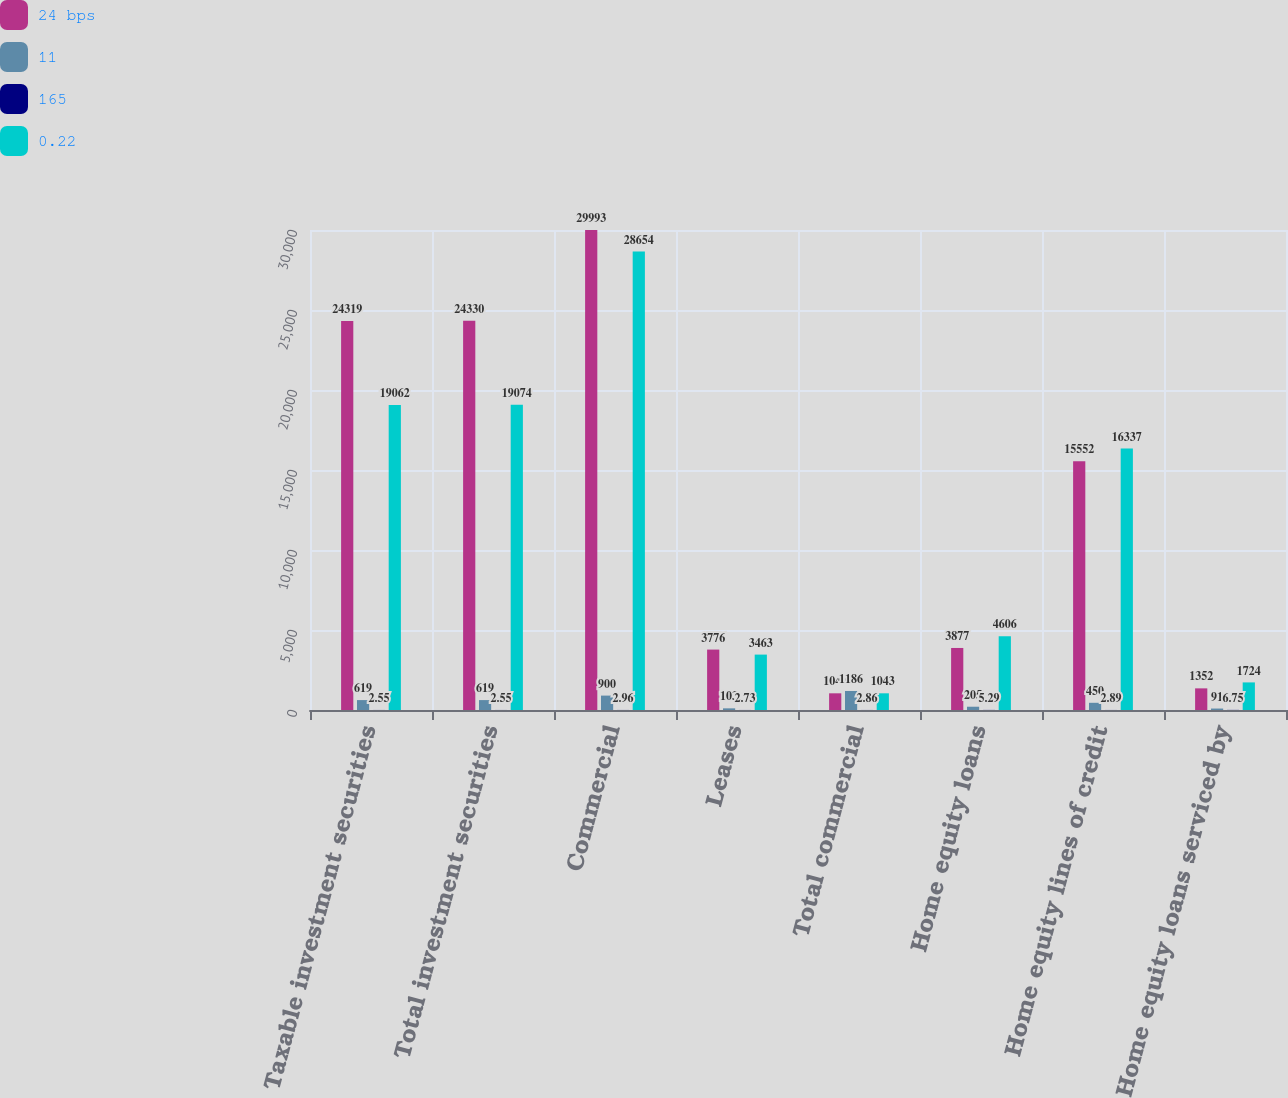Convert chart to OTSL. <chart><loc_0><loc_0><loc_500><loc_500><stacked_bar_chart><ecel><fcel>Taxable investment securities<fcel>Total investment securities<fcel>Commercial<fcel>Leases<fcel>Total commercial<fcel>Home equity loans<fcel>Home equity lines of credit<fcel>Home equity loans serviced by<nl><fcel>24 bps<fcel>24319<fcel>24330<fcel>29993<fcel>3776<fcel>1043<fcel>3877<fcel>15552<fcel>1352<nl><fcel>11<fcel>619<fcel>619<fcel>900<fcel>103<fcel>1186<fcel>205<fcel>450<fcel>91<nl><fcel>165<fcel>2.55<fcel>2.55<fcel>2.96<fcel>2.73<fcel>2.86<fcel>5.29<fcel>2.89<fcel>6.75<nl><fcel>0.22<fcel>19062<fcel>19074<fcel>28654<fcel>3463<fcel>1043<fcel>4606<fcel>16337<fcel>1724<nl></chart> 